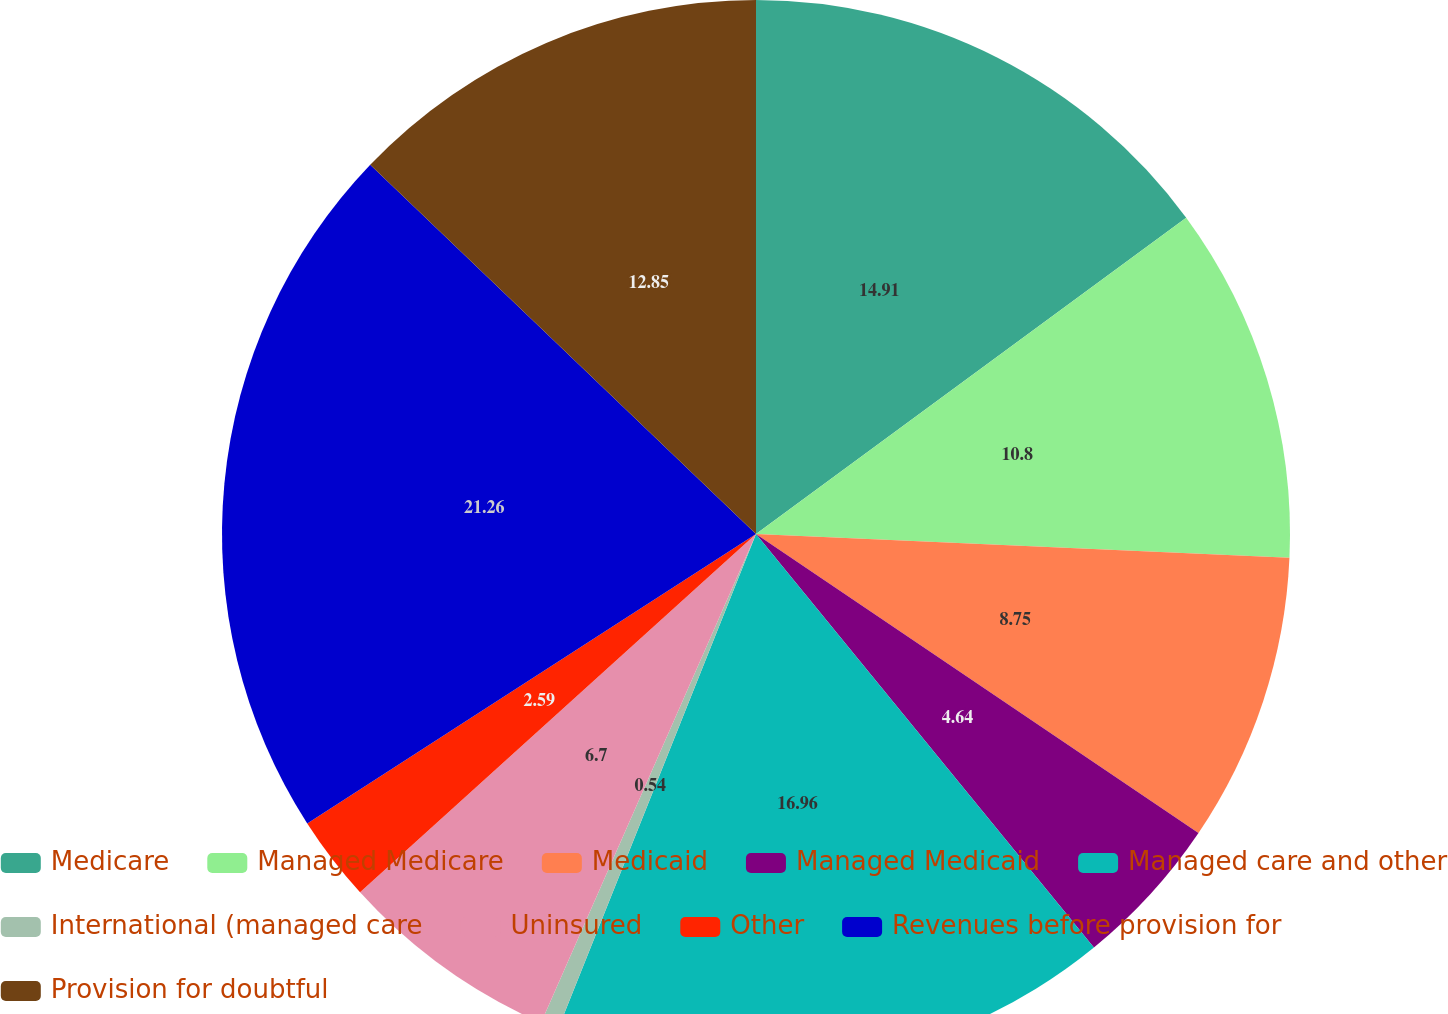<chart> <loc_0><loc_0><loc_500><loc_500><pie_chart><fcel>Medicare<fcel>Managed Medicare<fcel>Medicaid<fcel>Managed Medicaid<fcel>Managed care and other<fcel>International (managed care<fcel>Uninsured<fcel>Other<fcel>Revenues before provision for<fcel>Provision for doubtful<nl><fcel>14.91%<fcel>10.8%<fcel>8.75%<fcel>4.64%<fcel>16.96%<fcel>0.54%<fcel>6.7%<fcel>2.59%<fcel>21.27%<fcel>12.85%<nl></chart> 